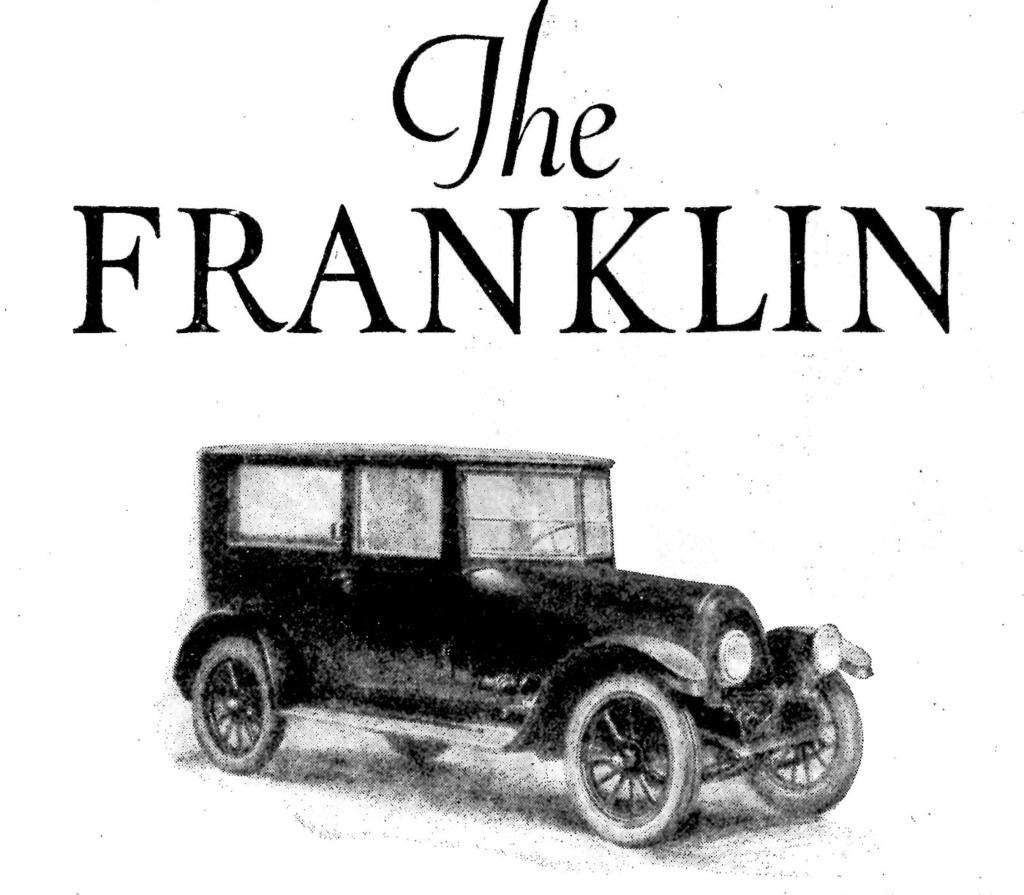What is depicted in the image? There is a drawing of a car in the image. What color is the car in the drawing? The car is black in color. Are there any words or letters on the car? Yes, there is text written on the car. Where is the family sitting in the image? There is no family present in the image; it only features a drawing of a black car with text on it. 